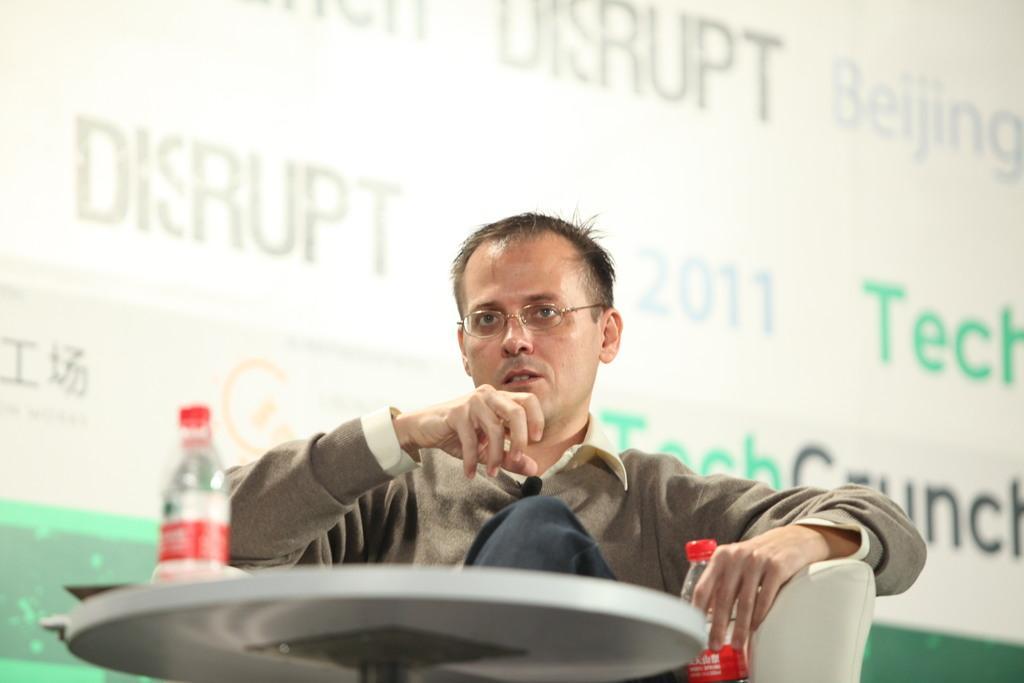Could you give a brief overview of what you see in this image? there is a person sitting on a chair Catching a water bottle with table in front him. 